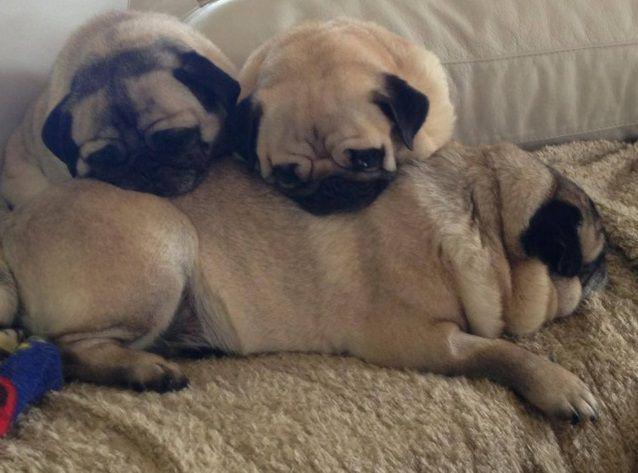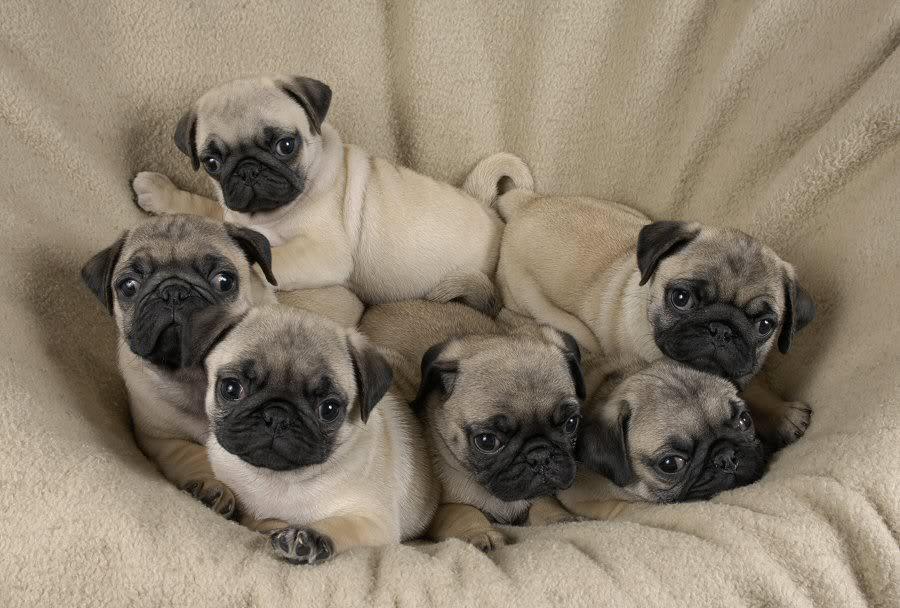The first image is the image on the left, the second image is the image on the right. For the images displayed, is the sentence "there are no more than three puppies in the image on the left." factually correct? Answer yes or no. Yes. The first image is the image on the left, the second image is the image on the right. Assess this claim about the two images: "There are more pug dogs in the right image than in the left.". Correct or not? Answer yes or no. Yes. 